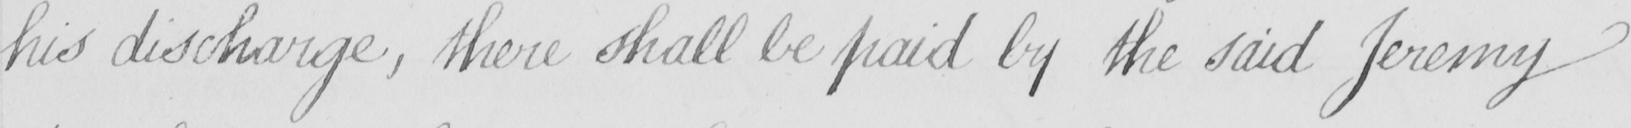Please transcribe the handwritten text in this image. his discharge , there shall be paid by the said Jeremy 